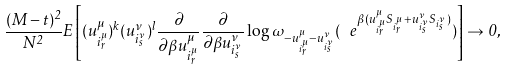<formula> <loc_0><loc_0><loc_500><loc_500>\frac { ( M - t ) ^ { 2 } } { N ^ { 2 } } E \left [ ( u _ { i _ { r } ^ { \mu } } ^ { \mu } ) ^ { k } ( u _ { i _ { s } ^ { \nu } } ^ { \nu } ) ^ { l } \frac { \partial } { \partial \beta u _ { i _ { r } ^ { \mu } } ^ { \mu } } \frac { \partial } { \partial \beta u _ { i _ { s } ^ { \nu } } ^ { \nu } } \log \omega _ { - u _ { i _ { r } ^ { \mu } } ^ { \mu } - u _ { i _ { s } ^ { \nu } } ^ { \nu } } ( \ e ^ { \beta ( u _ { i _ { r } ^ { \mu } } ^ { \mu } S _ { i _ { r } ^ { \mu } } + u _ { i _ { s } ^ { \nu } } ^ { \nu } S _ { i _ { s } ^ { \nu } } ) } ) \right ] \to 0 ,</formula> 